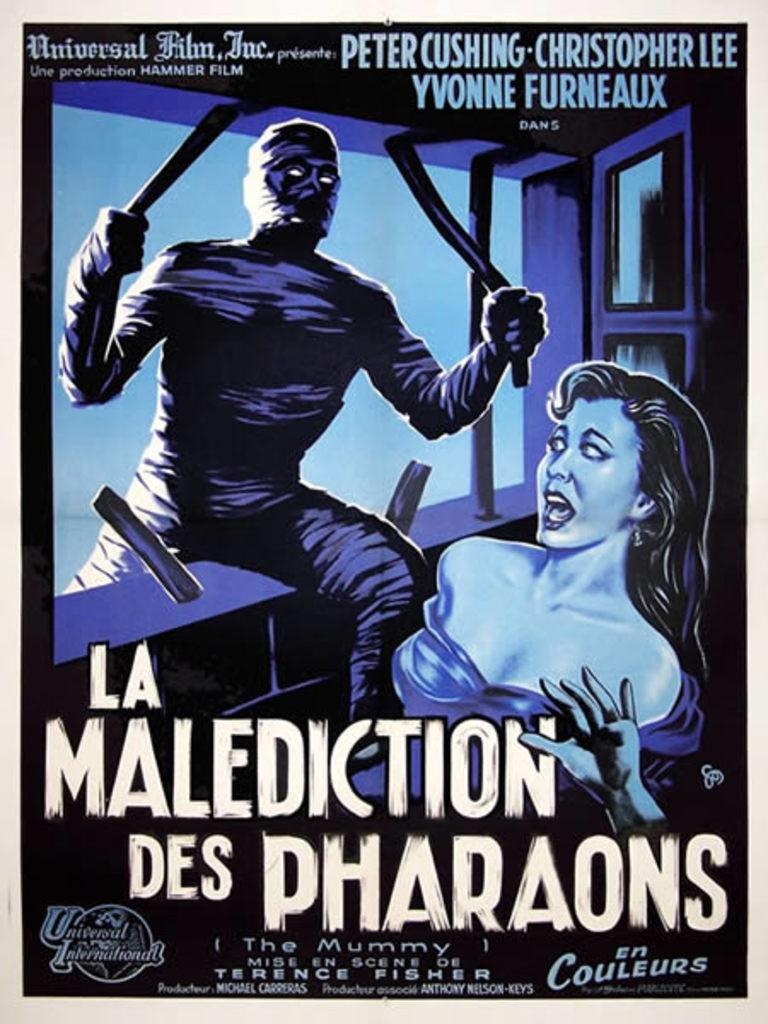<image>
Create a compact narrative representing the image presented. A poster advertises a Universal Film, Inc movie. 